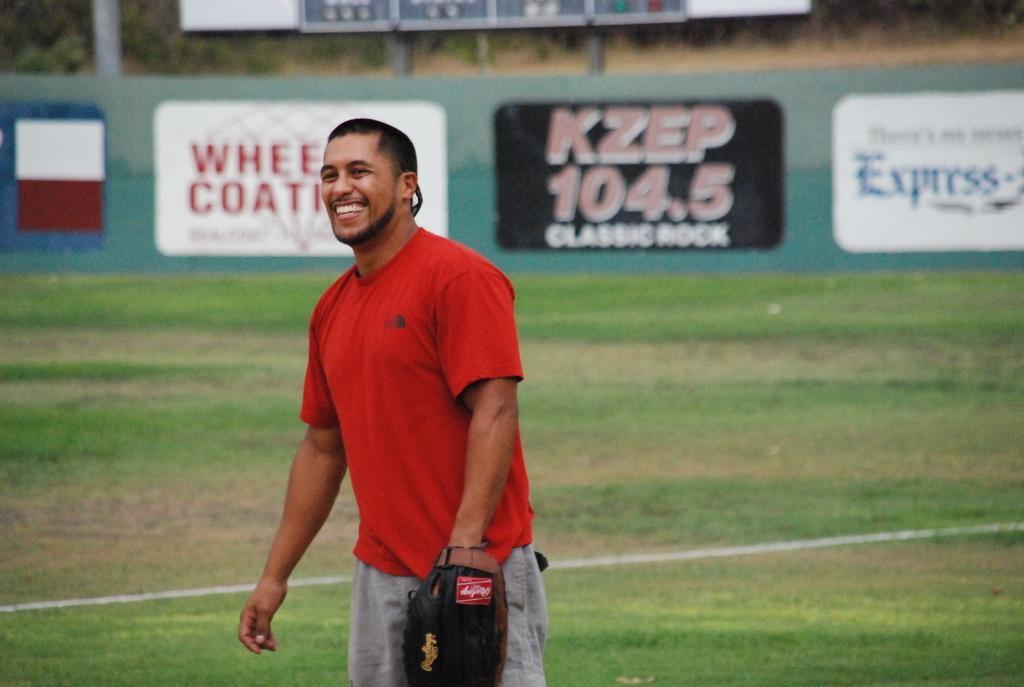In one or two sentences, can you explain what this image depicts? In this picture we can see a man wearing a glove and standing on the ground and smiling and in the background we can see an advertisement board. 